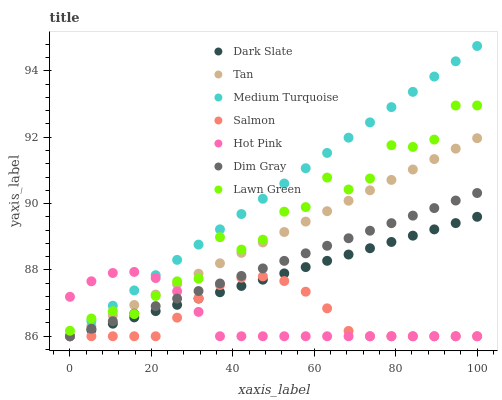Does Hot Pink have the minimum area under the curve?
Answer yes or no. Yes. Does Medium Turquoise have the maximum area under the curve?
Answer yes or no. Yes. Does Dim Gray have the minimum area under the curve?
Answer yes or no. No. Does Dim Gray have the maximum area under the curve?
Answer yes or no. No. Is Medium Turquoise the smoothest?
Answer yes or no. Yes. Is Lawn Green the roughest?
Answer yes or no. Yes. Is Dim Gray the smoothest?
Answer yes or no. No. Is Dim Gray the roughest?
Answer yes or no. No. Does Dim Gray have the lowest value?
Answer yes or no. Yes. Does Medium Turquoise have the highest value?
Answer yes or no. Yes. Does Dim Gray have the highest value?
Answer yes or no. No. Is Salmon less than Lawn Green?
Answer yes or no. Yes. Is Lawn Green greater than Dark Slate?
Answer yes or no. Yes. Does Tan intersect Salmon?
Answer yes or no. Yes. Is Tan less than Salmon?
Answer yes or no. No. Is Tan greater than Salmon?
Answer yes or no. No. Does Salmon intersect Lawn Green?
Answer yes or no. No. 